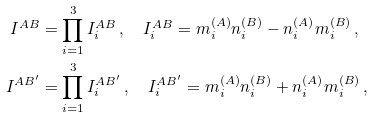<formula> <loc_0><loc_0><loc_500><loc_500>I ^ { A B } & = \prod _ { i = 1 } ^ { 3 } I _ { i } ^ { A B } \, , \quad I _ { i } ^ { A B } = m _ { i } ^ { ( A ) } n _ { i } ^ { ( B ) } - n _ { i } ^ { ( A ) } m _ { i } ^ { ( B ) } \, , \\ I ^ { A B ^ { \prime } } & = \prod _ { i = 1 } ^ { 3 } I _ { i } ^ { A B ^ { \prime } } \, , \quad I _ { i } ^ { A B ^ { \prime } } = m _ { i } ^ { ( A ) } n _ { i } ^ { ( B ) } + n _ { i } ^ { ( A ) } m _ { i } ^ { ( B ) } \, , \\</formula> 